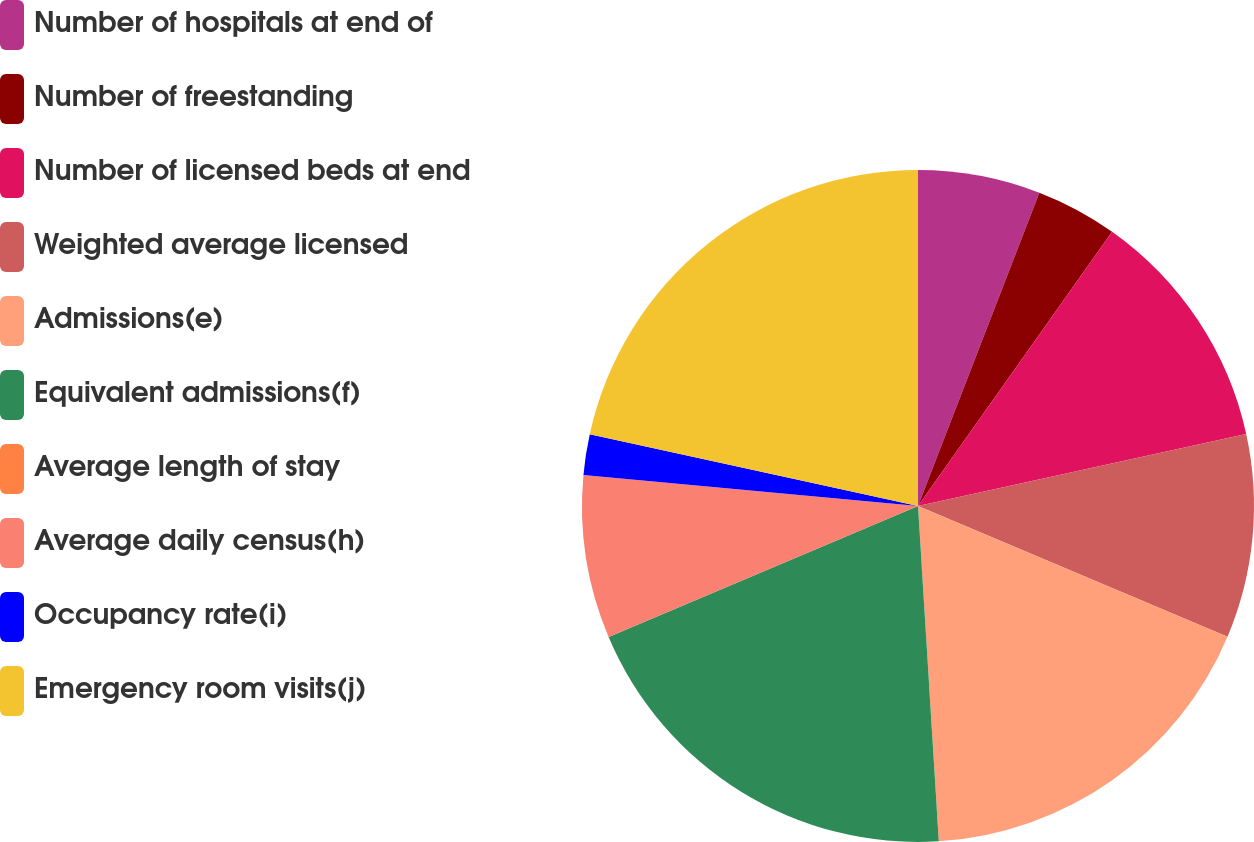Convert chart to OTSL. <chart><loc_0><loc_0><loc_500><loc_500><pie_chart><fcel>Number of hospitals at end of<fcel>Number of freestanding<fcel>Number of licensed beds at end<fcel>Weighted average licensed<fcel>Admissions(e)<fcel>Equivalent admissions(f)<fcel>Average length of stay<fcel>Average daily census(h)<fcel>Occupancy rate(i)<fcel>Emergency room visits(j)<nl><fcel>5.88%<fcel>3.92%<fcel>11.76%<fcel>9.8%<fcel>17.65%<fcel>19.61%<fcel>0.0%<fcel>7.84%<fcel>1.96%<fcel>21.57%<nl></chart> 